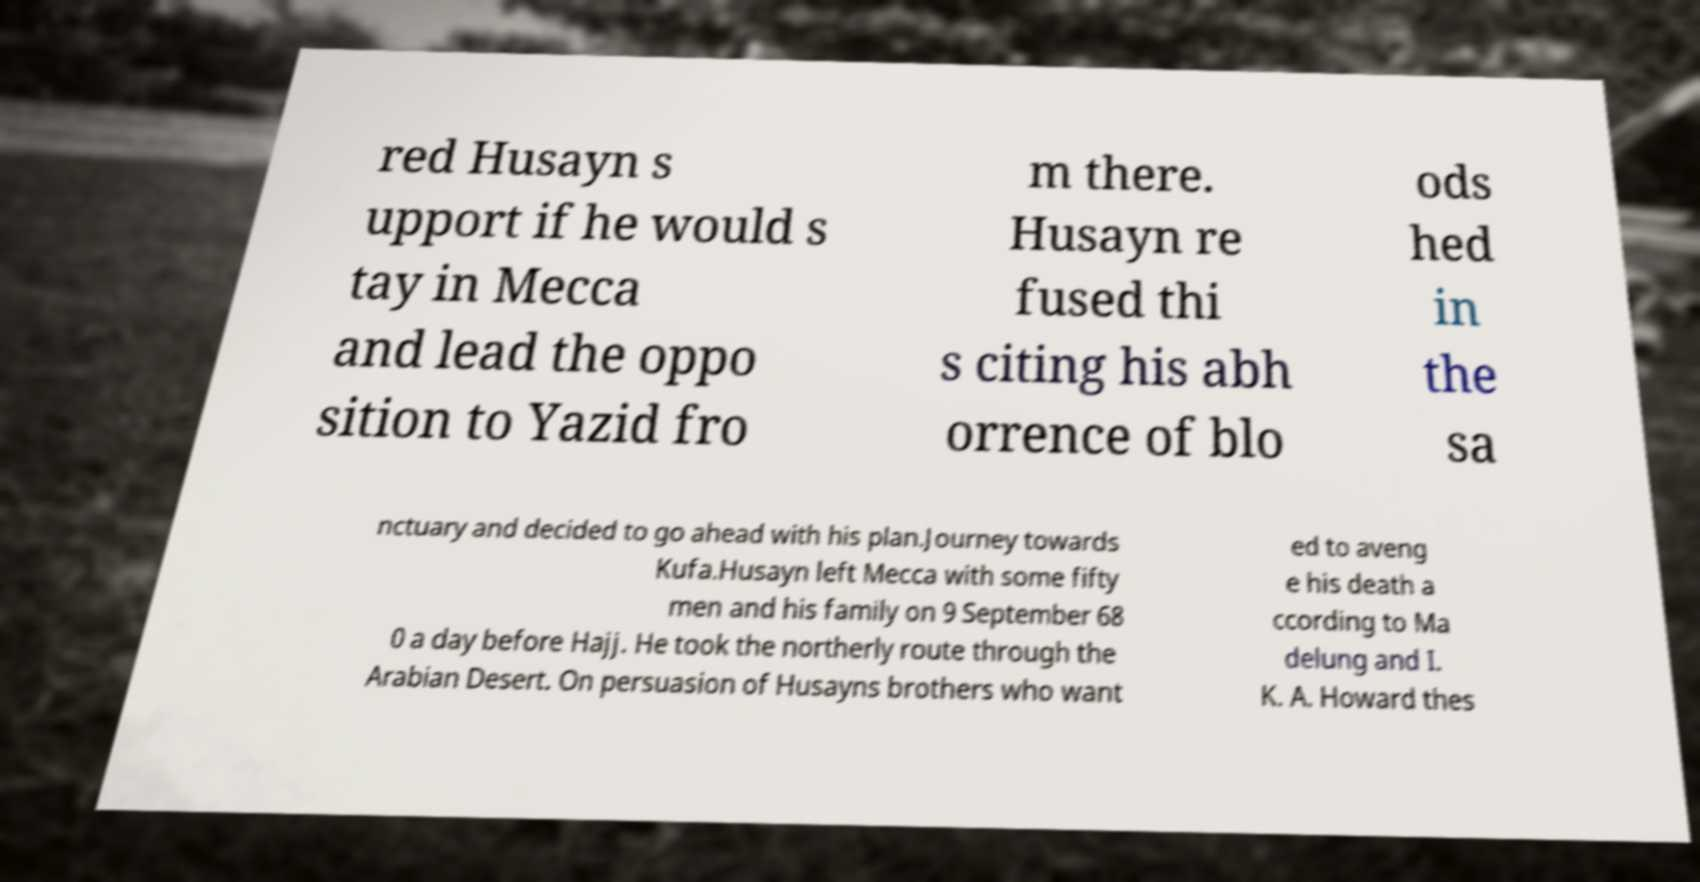Could you extract and type out the text from this image? red Husayn s upport if he would s tay in Mecca and lead the oppo sition to Yazid fro m there. Husayn re fused thi s citing his abh orrence of blo ods hed in the sa nctuary and decided to go ahead with his plan.Journey towards Kufa.Husayn left Mecca with some fifty men and his family on 9 September 68 0 a day before Hajj. He took the northerly route through the Arabian Desert. On persuasion of Husayns brothers who want ed to aveng e his death a ccording to Ma delung and I. K. A. Howard thes 